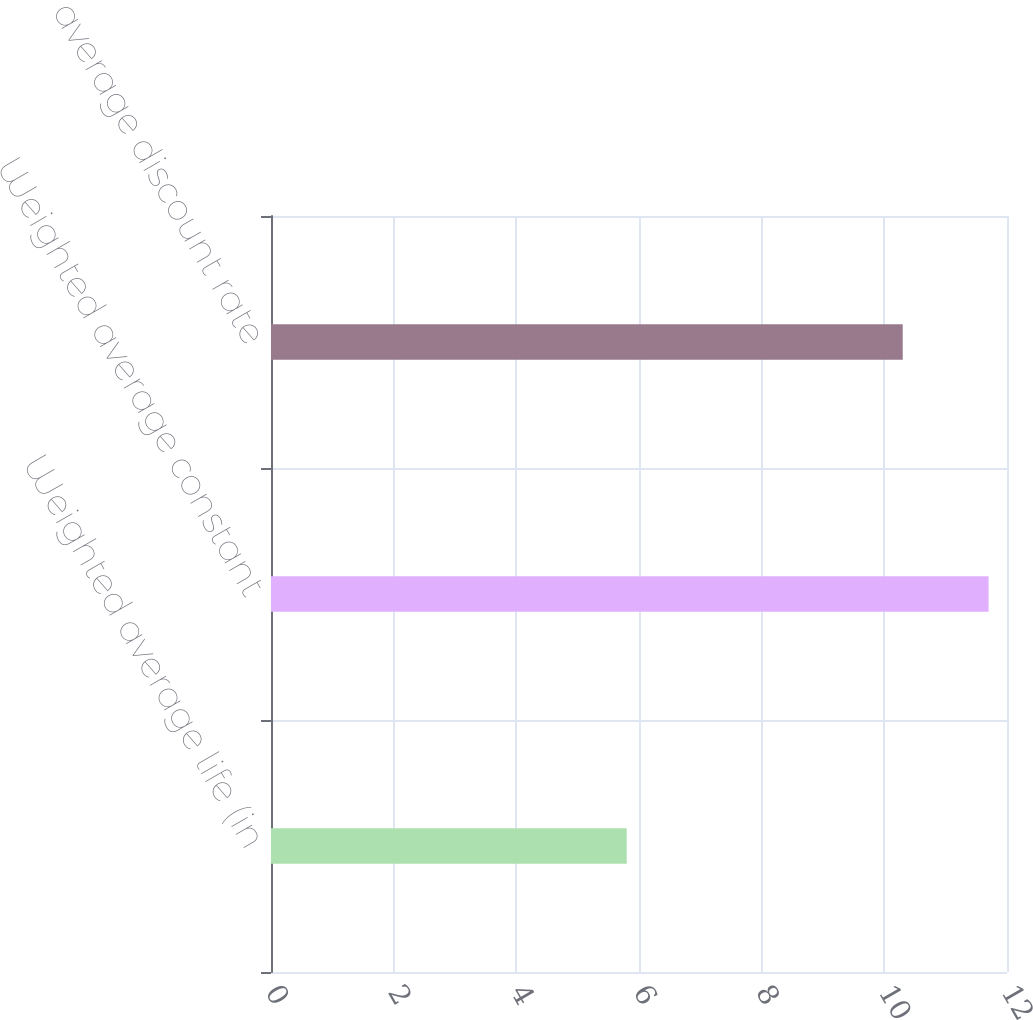Convert chart. <chart><loc_0><loc_0><loc_500><loc_500><bar_chart><fcel>Weighted average life (in<fcel>Weighted average constant<fcel>Weighted average discount rate<nl><fcel>5.8<fcel>11.7<fcel>10.3<nl></chart> 